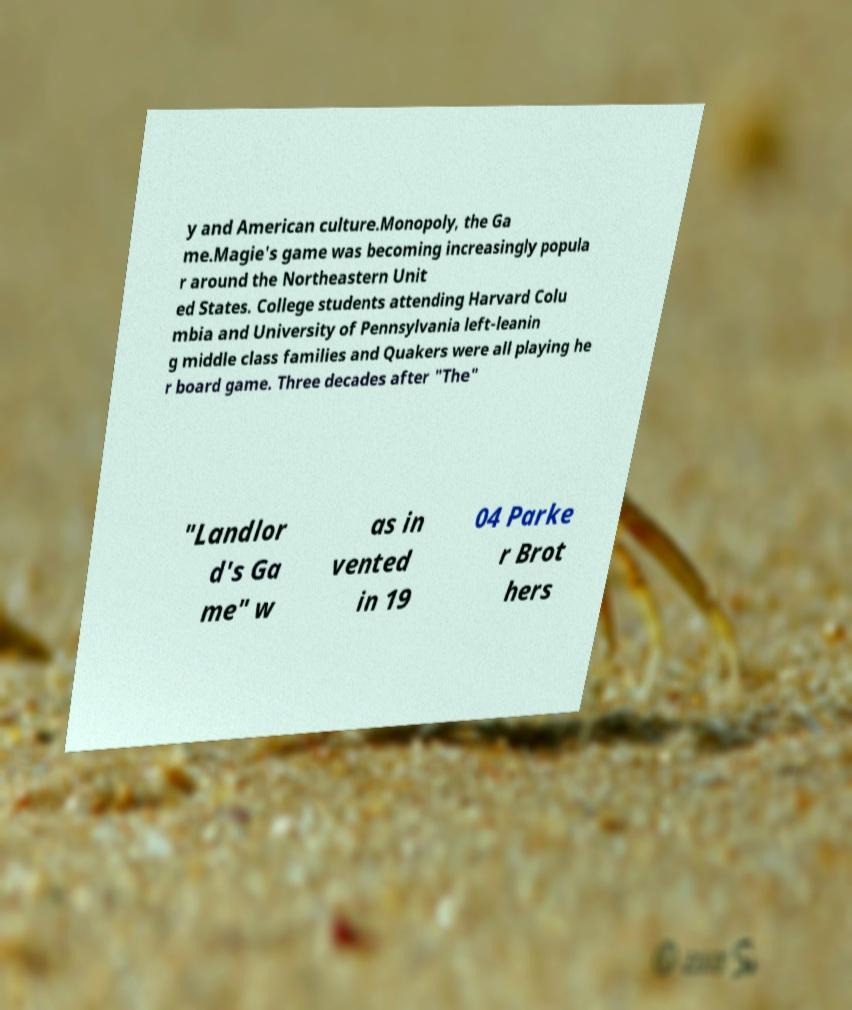I need the written content from this picture converted into text. Can you do that? y and American culture.Monopoly, the Ga me.Magie's game was becoming increasingly popula r around the Northeastern Unit ed States. College students attending Harvard Colu mbia and University of Pennsylvania left-leanin g middle class families and Quakers were all playing he r board game. Three decades after "The" "Landlor d's Ga me" w as in vented in 19 04 Parke r Brot hers 